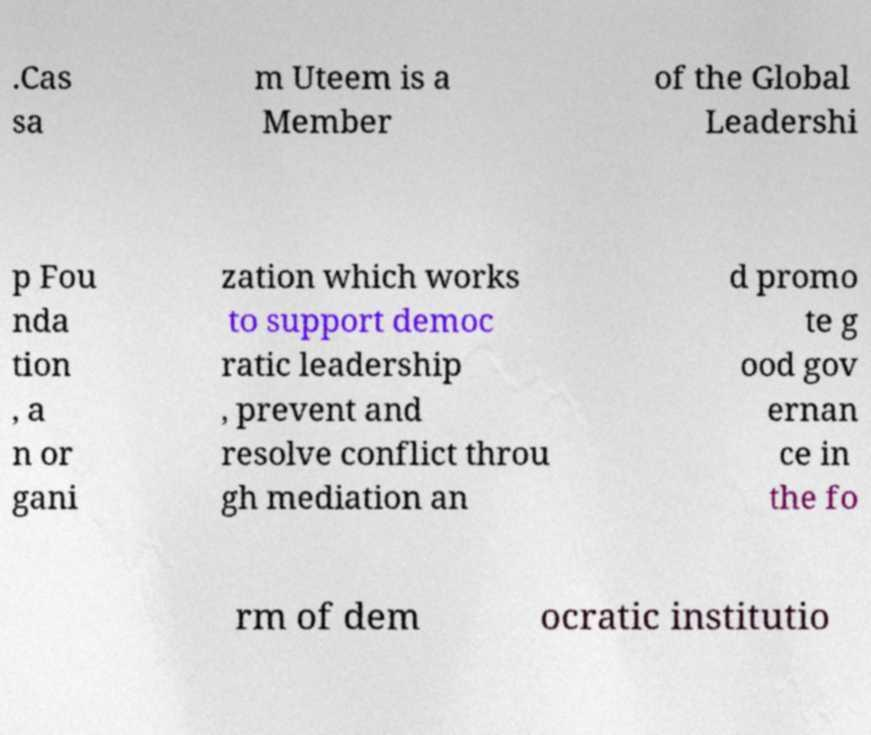Could you extract and type out the text from this image? .Cas sa m Uteem is a Member of the Global Leadershi p Fou nda tion , a n or gani zation which works to support democ ratic leadership , prevent and resolve conflict throu gh mediation an d promo te g ood gov ernan ce in the fo rm of dem ocratic institutio 